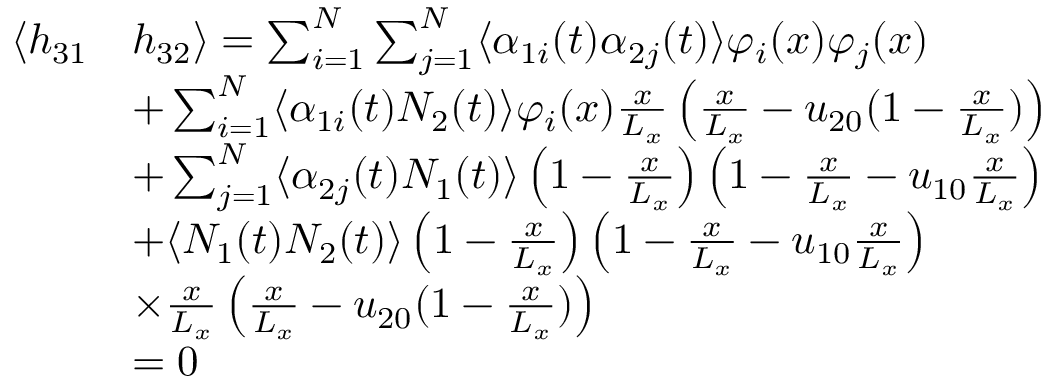Convert formula to latex. <formula><loc_0><loc_0><loc_500><loc_500>\begin{array} { r l } { \langle h _ { 3 1 } } & { h _ { 3 2 } \rangle = \sum _ { i = 1 } ^ { N } \sum _ { j = 1 } ^ { N } \langle \alpha _ { 1 i } ( t ) \alpha _ { 2 j } ( t ) \rangle \varphi _ { i } ( x ) \varphi _ { j } ( x ) } \\ & { + \sum _ { i = 1 } ^ { N } \langle \alpha _ { 1 i } ( t ) N _ { 2 } ( t ) \rangle \varphi _ { i } ( x ) \frac { x } { L _ { x } } \left ( \frac { x } { L _ { x } } - u _ { 2 0 } ( 1 - \frac { x } { L _ { x } } ) \right ) } \\ & { + \sum _ { j = 1 } ^ { N } \langle \alpha _ { 2 j } ( t ) N _ { 1 } ( t ) \rangle \left ( 1 - \frac { x } { L _ { x } } \right ) \left ( 1 - \frac { x } { L _ { x } } - u _ { 1 0 } \frac { x } { L _ { x } } \right ) } \\ & { + \langle N _ { 1 } ( t ) N _ { 2 } ( t ) \rangle \left ( 1 - \frac { x } { L _ { x } } \right ) \left ( 1 - \frac { x } { L _ { x } } - u _ { 1 0 } \frac { x } { L _ { x } } \right ) } \\ & { \times \frac { x } { L _ { x } } \left ( \frac { x } { L _ { x } } - u _ { 2 0 } ( 1 - \frac { x } { L _ { x } } ) \right ) } \\ & { = 0 } \end{array}</formula> 